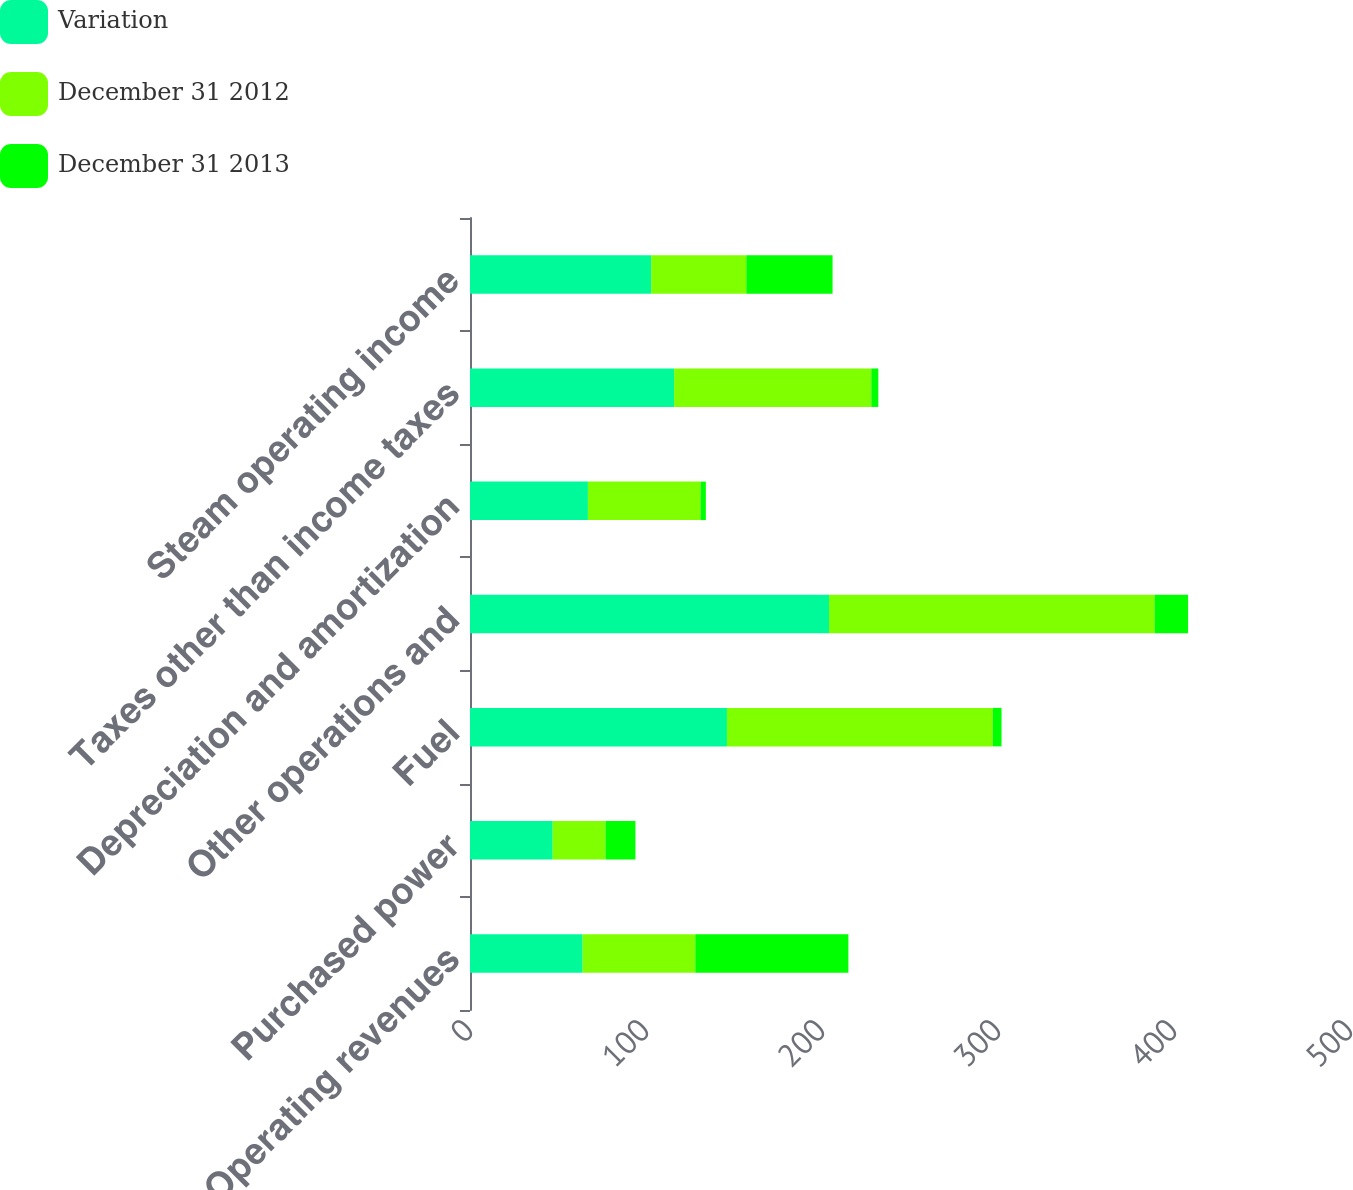<chart> <loc_0><loc_0><loc_500><loc_500><stacked_bar_chart><ecel><fcel>Operating revenues<fcel>Purchased power<fcel>Fuel<fcel>Other operations and<fcel>Depreciation and amortization<fcel>Taxes other than income taxes<fcel>Steam operating income<nl><fcel>Variation<fcel>64<fcel>47<fcel>146<fcel>204<fcel>67<fcel>116<fcel>103<nl><fcel>December 31 2012<fcel>64<fcel>30<fcel>151<fcel>185<fcel>64<fcel>112<fcel>54<nl><fcel>December 31 2013<fcel>87<fcel>17<fcel>5<fcel>19<fcel>3<fcel>4<fcel>49<nl></chart> 